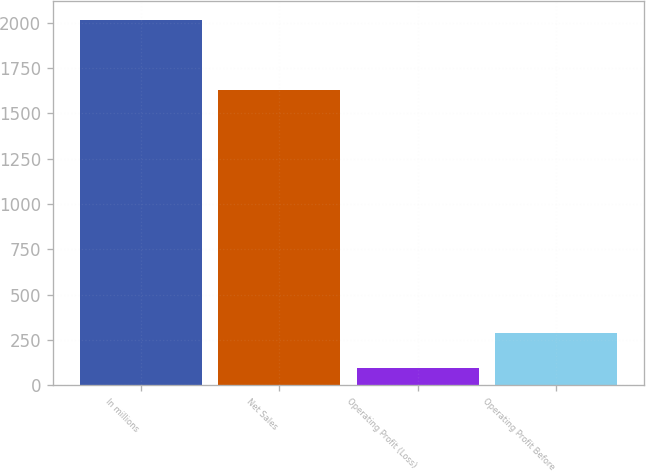<chart> <loc_0><loc_0><loc_500><loc_500><bar_chart><fcel>In millions<fcel>Net Sales<fcel>Operating Profit (Loss)<fcel>Operating Profit Before<nl><fcel>2016<fcel>1628<fcel>98<fcel>289.8<nl></chart> 